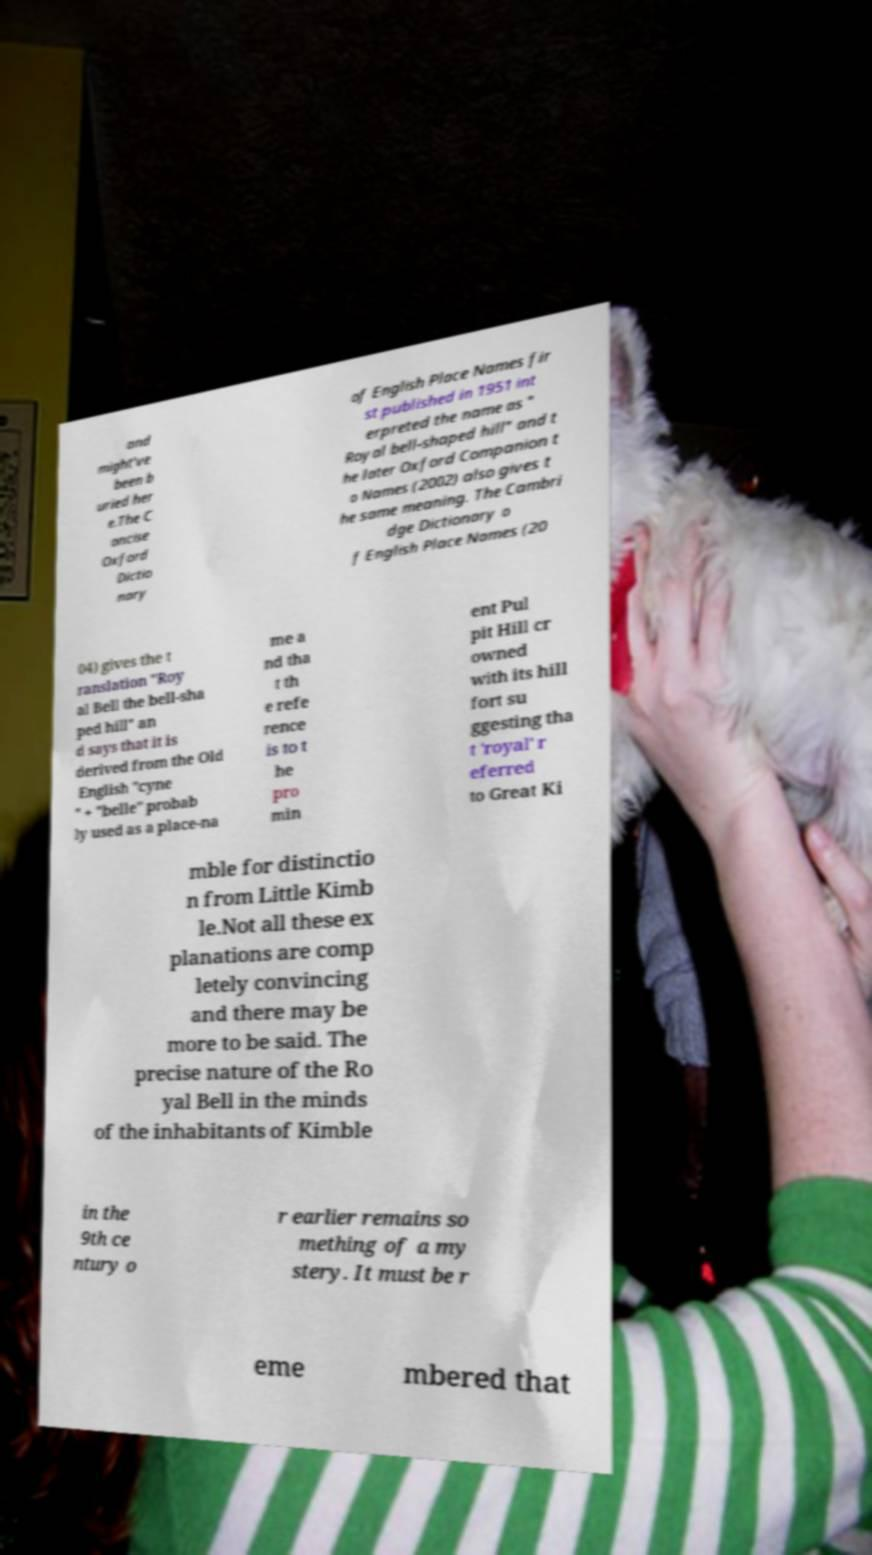Please read and relay the text visible in this image. What does it say? and might've been b uried her e.The C oncise Oxford Dictio nary of English Place Names fir st published in 1951 int erpreted the name as " Royal bell-shaped hill" and t he later Oxford Companion t o Names (2002) also gives t he same meaning. The Cambri dge Dictionary o f English Place Names (20 04) gives the t ranslation "Roy al Bell the bell-sha ped hill" an d says that it is derived from the Old English "cyne " + "belle" probab ly used as a place-na me a nd tha t th e refe rence is to t he pro min ent Pul pit Hill cr owned with its hill fort su ggesting tha t 'royal' r eferred to Great Ki mble for distinctio n from Little Kimb le.Not all these ex planations are comp letely convincing and there may be more to be said. The precise nature of the Ro yal Bell in the minds of the inhabitants of Kimble in the 9th ce ntury o r earlier remains so mething of a my stery. It must be r eme mbered that 